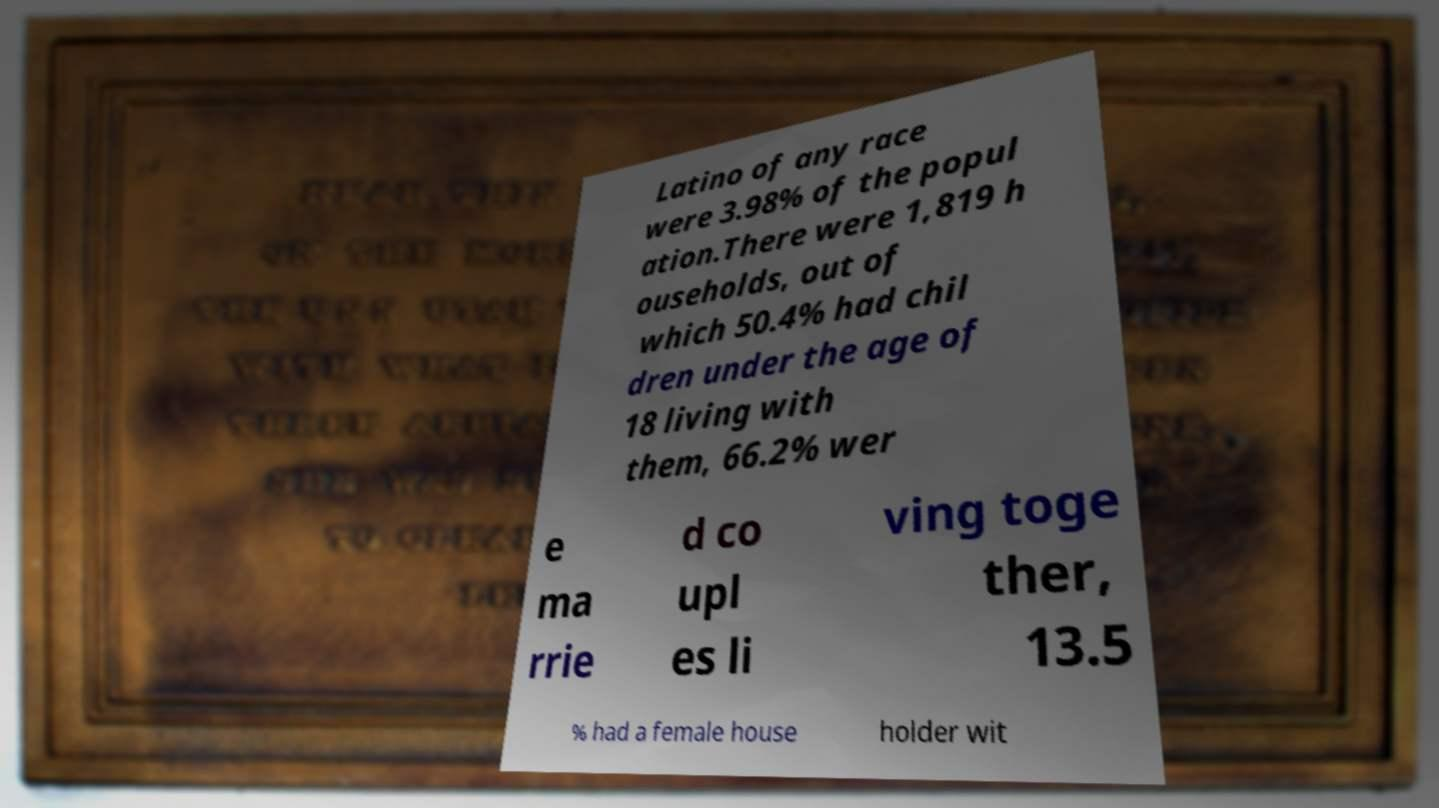Please identify and transcribe the text found in this image. Latino of any race were 3.98% of the popul ation.There were 1,819 h ouseholds, out of which 50.4% had chil dren under the age of 18 living with them, 66.2% wer e ma rrie d co upl es li ving toge ther, 13.5 % had a female house holder wit 